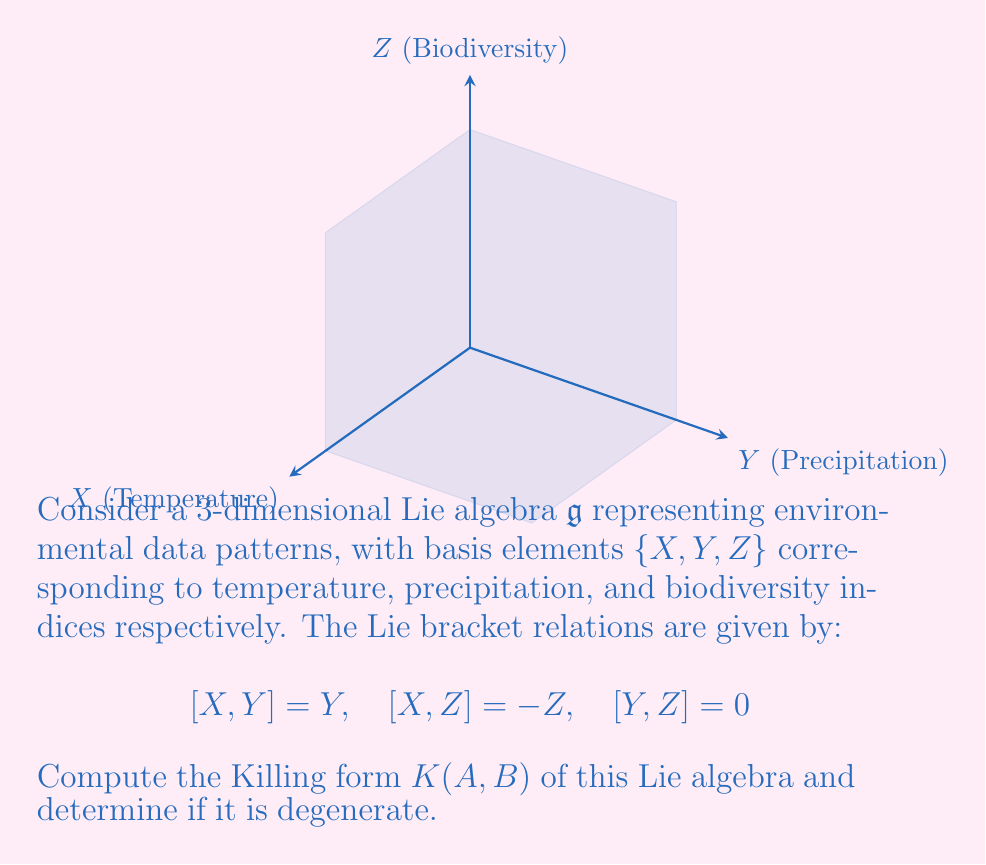Give your solution to this math problem. Let's approach this step-by-step:

1) The Killing form is defined as $K(A,B) = \text{tr}(\text{ad}_A \circ \text{ad}_B)$, where $\text{ad}_A$ is the adjoint representation of $A$.

2) First, we need to find the matrix representations of $\text{ad}_X$, $\text{ad}_Y$, and $\text{ad}_Z$:

   $\text{ad}_X = \begin{pmatrix} 0 & 0 & 0 \\ 0 & 1 & 0 \\ 0 & 0 & -1 \end{pmatrix}$
   
   $\text{ad}_Y = \begin{pmatrix} 0 & -1 & 0 \\ 0 & 0 & 0 \\ 0 & 0 & 0 \end{pmatrix}$
   
   $\text{ad}_Z = \begin{pmatrix} 0 & 0 & 1 \\ 0 & 0 & 0 \\ 0 & 0 & 0 \end{pmatrix}$

3) Now, we compute $K(X,X)$, $K(Y,Y)$, $K(Z,Z)$, $K(X,Y)$, $K(X,Z)$, and $K(Y,Z)$:

   $K(X,X) = \text{tr}(\text{ad}_X \circ \text{ad}_X) = \text{tr}(\begin{pmatrix} 0 & 0 & 0 \\ 0 & 1 & 0 \\ 0 & 0 & 1 \end{pmatrix}) = 2$
   
   $K(Y,Y) = \text{tr}(\text{ad}_Y \circ \text{ad}_Y) = \text{tr}(\begin{pmatrix} 0 & 0 & 0 \\ 0 & 0 & 0 \\ 0 & 0 & 0 \end{pmatrix}) = 0$
   
   $K(Z,Z) = \text{tr}(\text{ad}_Z \circ \text{ad}_Z) = \text{tr}(\begin{pmatrix} 0 & 0 & 0 \\ 0 & 0 & 0 \\ 0 & 0 & 0 \end{pmatrix}) = 0$
   
   $K(X,Y) = \text{tr}(\text{ad}_X \circ \text{ad}_Y) = \text{tr}(\begin{pmatrix} 0 & -1 & 0 \\ 0 & 0 & 0 \\ 0 & 0 & 0 \end{pmatrix}) = 0$
   
   $K(X,Z) = \text{tr}(\text{ad}_X \circ \text{ad}_Z) = \text{tr}(\begin{pmatrix} 0 & 0 & 1 \\ 0 & 0 & 0 \\ 0 & 0 & 0 \end{pmatrix}) = 0$
   
   $K(Y,Z) = \text{tr}(\text{ad}_Y \circ \text{ad}_Z) = \text{tr}(\begin{pmatrix} 0 & 0 & 0 \\ 0 & 0 & 0 \\ 0 & 0 & 0 \end{pmatrix}) = 0$

4) The Killing form matrix is thus:

   $K = \begin{pmatrix} 2 & 0 & 0 \\ 0 & 0 & 0 \\ 0 & 0 & 0 \end{pmatrix}$

5) The Killing form is degenerate if its determinant is zero. Here, $\det(K) = 0$, so the Killing form is degenerate.
Answer: $K = \begin{pmatrix} 2 & 0 & 0 \\ 0 & 0 & 0 \\ 0 & 0 & 0 \end{pmatrix}$, degenerate 